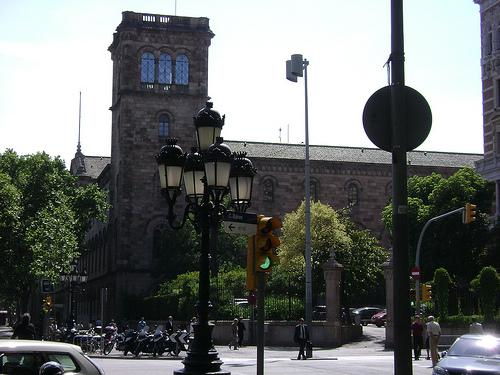Question: how many traffic lights are visible in the picture?
Choices:
A. Two.
B. Three.
C. Four.
D. One.
Answer with the letter. Answer: B Question: how many lamps are attached to the black lamp stand in the forefront of the picture?
Choices:
A. Five.
B. Four.
C. Three.
D. Two.
Answer with the letter. Answer: A Question: where is this scene taking place?
Choices:
A. Suburb.
B. Farm.
C. City.
D. City Park.
Answer with the letter. Answer: C Question: when is this scene taking place?
Choices:
A. Nighttime.
B. Lunchtime.
C. Evening.
D. Daytime.
Answer with the letter. Answer: D Question: what shape is the sign attached to the black pole on the right of the photo?
Choices:
A. Circle.
B. Octagon.
C. Square.
D. Arrow-shaped.
Answer with the letter. Answer: A Question: what direction is the arrow pointing in on the sign between the black lampost and the yellow traffic light?
Choices:
A. Right.
B. Northwest.
C. Northeast.
D. Left.
Answer with the letter. Answer: D 